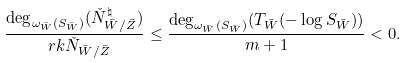Convert formula to latex. <formula><loc_0><loc_0><loc_500><loc_500>\frac { \deg _ { \omega _ { \bar { W } } ( S _ { \bar { W } } ) } ( \check { N } ^ { \natural } _ { \bar { W } / \bar { Z } } ) } { \ r k \check { N } _ { \bar { W } / \bar { Z } } } \leq \frac { \deg _ { \omega _ { \bar { W } } ( S _ { \bar { W } } ) } ( T _ { \bar { W } } ( - \log S _ { \bar { W } } ) ) } { m + 1 } < 0 .</formula> 